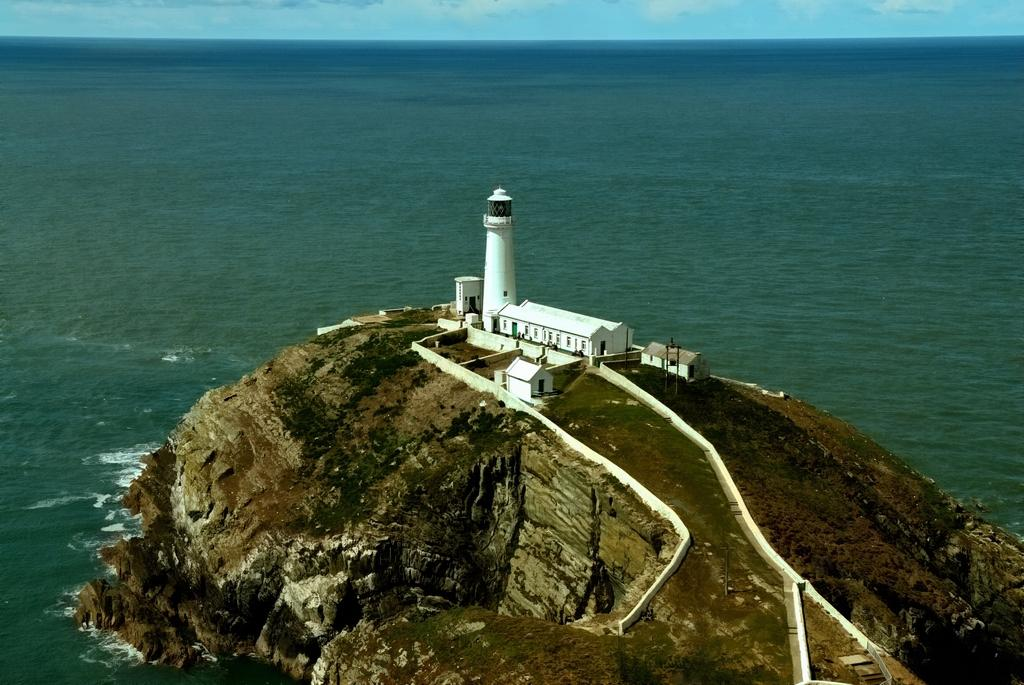What is the main feature of the image? There is an island in the image. What structure can be seen on the island? There is a lighthouse on the island. Are there any other structures on the island? Yes, there are buildings on the island. What can be seen in the background of the image? The sky is visible in the background of the image. What type of apparatus is being used to destroy the buildings on the island in the image? There is no apparatus being used to destroy the buildings in the image; the buildings appear to be intact. What color is the coat worn by the person on the island in the image? There are no people visible in the image, so it is not possible to determine the color of a coat. 